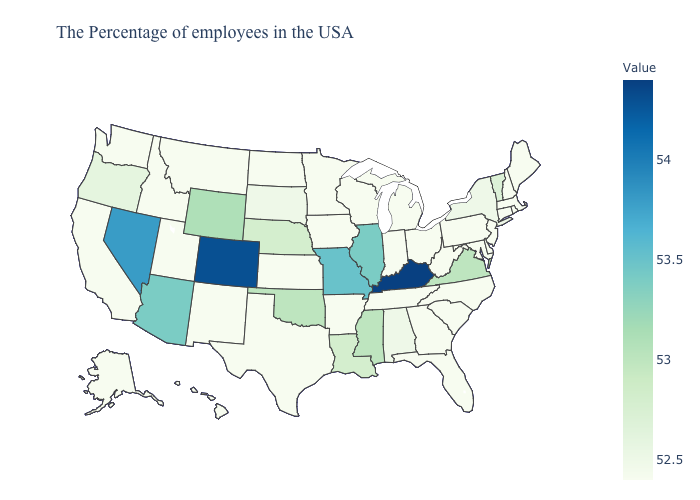Does Kentucky have the highest value in the USA?
Be succinct. Yes. Does Kentucky have the highest value in the South?
Concise answer only. Yes. Among the states that border Wyoming , does South Dakota have the highest value?
Answer briefly. No. Does Colorado have the highest value in the USA?
Short answer required. No. Does Louisiana have a lower value than New York?
Give a very brief answer. No. Which states have the lowest value in the West?
Be succinct. New Mexico, Utah, Montana, Idaho, California, Washington, Alaska, Hawaii. 